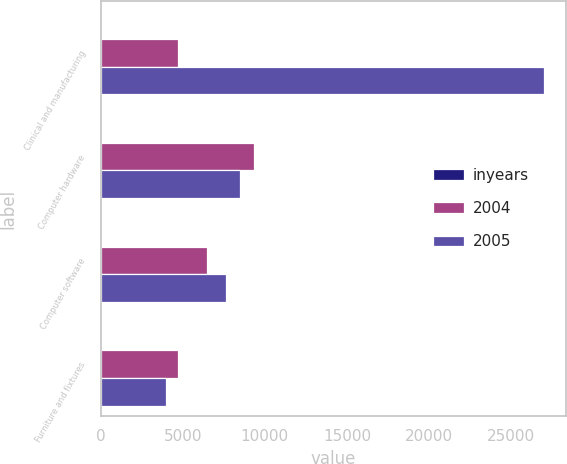Convert chart. <chart><loc_0><loc_0><loc_500><loc_500><stacked_bar_chart><ecel><fcel>Clinical and manufacturing<fcel>Computer hardware<fcel>Computer software<fcel>Furniture and fixtures<nl><fcel>inyears<fcel>5<fcel>3<fcel>3<fcel>5<nl><fcel>2004<fcel>4698<fcel>9352<fcel>6498<fcel>4698<nl><fcel>2005<fcel>26999<fcel>8503<fcel>7620<fcel>3977<nl></chart> 